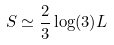Convert formula to latex. <formula><loc_0><loc_0><loc_500><loc_500>S \simeq \frac { 2 } { 3 } \log ( 3 ) L</formula> 